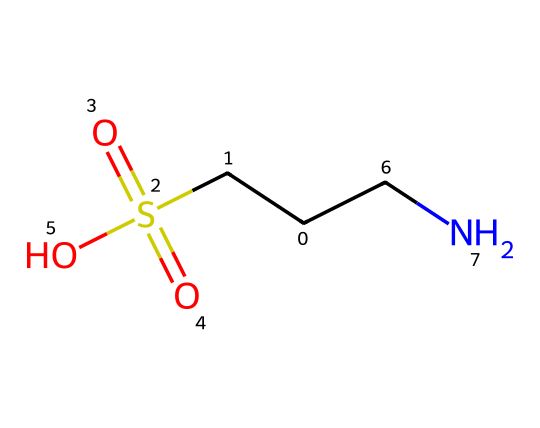What is the molecular formula of taurine? The molecular formula can be derived from the provided SMILES representation by counting the different types of atoms present. In the SMILES, we can see one C (carbon), one S (sulfur), two O (oxygen), and one N (nitrogen) along with additional H (hydrogen) atoms. Compiling these gives the formula C2H7NO3S.
Answer: C2H7NO3S How many carbon atoms are in taurine? By analyzing the SMILES representation, we can see there are two instances of the letter 'C', which indicates there are two carbon atoms in the structure.
Answer: 2 What functional groups are present in taurine? By examining the structure, taurine contains a sulfonic acid group (the -SO3H) indicated by the 'S(=O)(=O)O' part. Additionally, it has an amine group due to the presence of 'N' in the structure. This combination results in a sulfonic acid and an amine functional group.
Answer: sulfonic acid, amine What is the role of the sulfur atom in taurine? The sulfur atom in taurine forms part of the sulfonic acid group, making taurine a sulfonic acid, which is important for its functionality in biological systems and contributes to its solubility in water.
Answer: sulfonic acid group What type of medicinal compound is taurine classified as? Taurine is classified as an amino sulfonic acid due to its structure that contains both an amino group ('NH2') and a sulfonic acid group ('SO3H'). This classification is based on its unique functional groups that differentiate it from simple amino acids.
Answer: amino sulfonic acid 